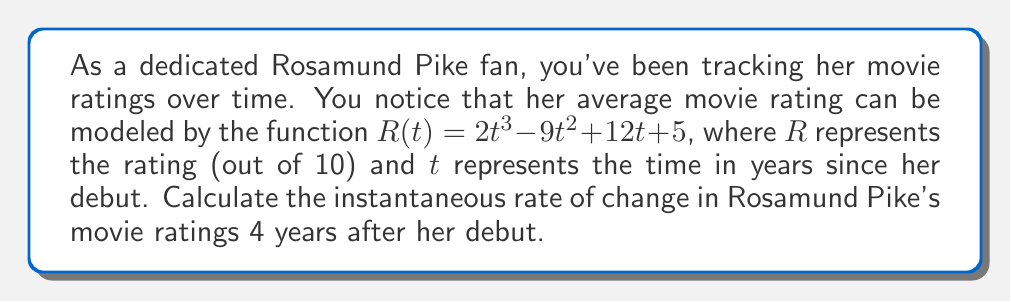Can you answer this question? To find the instantaneous rate of change in Rosamund Pike's movie ratings 4 years after her debut, we need to calculate the derivative of the given function $R(t)$ and then evaluate it at $t = 4$.

1. Given function: $R(t) = 2t^3 - 9t^2 + 12t + 5$

2. To find the derivative, we apply the power rule and constant rule:
   $$\frac{dR}{dt} = 6t^2 - 18t + 12$$

3. Now, we evaluate the derivative at $t = 4$:
   $$\frac{dR}{dt}\bigg|_{t=4} = 6(4)^2 - 18(4) + 12$$
   $$= 6(16) - 72 + 12$$
   $$= 96 - 72 + 12$$
   $$= 36$$

The result, 36, represents the instantaneous rate of change in ratings per year at $t = 4$.
Answer: The instantaneous rate of change in Rosamund Pike's movie ratings 4 years after her debut is 36 rating points per year. 